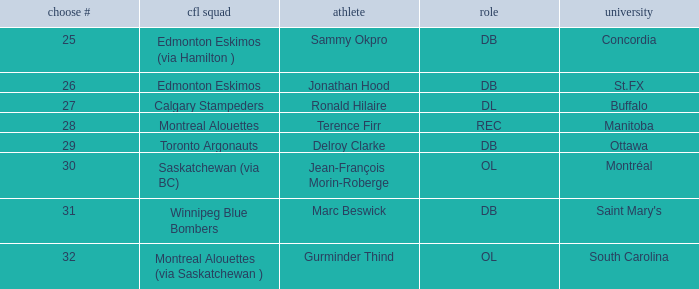Which Pick # has a College of concordia? 25.0. Can you give me this table as a dict? {'header': ['choose #', 'cfl squad', 'athlete', 'role', 'university'], 'rows': [['25', 'Edmonton Eskimos (via Hamilton )', 'Sammy Okpro', 'DB', 'Concordia'], ['26', 'Edmonton Eskimos', 'Jonathan Hood', 'DB', 'St.FX'], ['27', 'Calgary Stampeders', 'Ronald Hilaire', 'DL', 'Buffalo'], ['28', 'Montreal Alouettes', 'Terence Firr', 'REC', 'Manitoba'], ['29', 'Toronto Argonauts', 'Delroy Clarke', 'DB', 'Ottawa'], ['30', 'Saskatchewan (via BC)', 'Jean-François Morin-Roberge', 'OL', 'Montréal'], ['31', 'Winnipeg Blue Bombers', 'Marc Beswick', 'DB', "Saint Mary's"], ['32', 'Montreal Alouettes (via Saskatchewan )', 'Gurminder Thind', 'OL', 'South Carolina']]} 